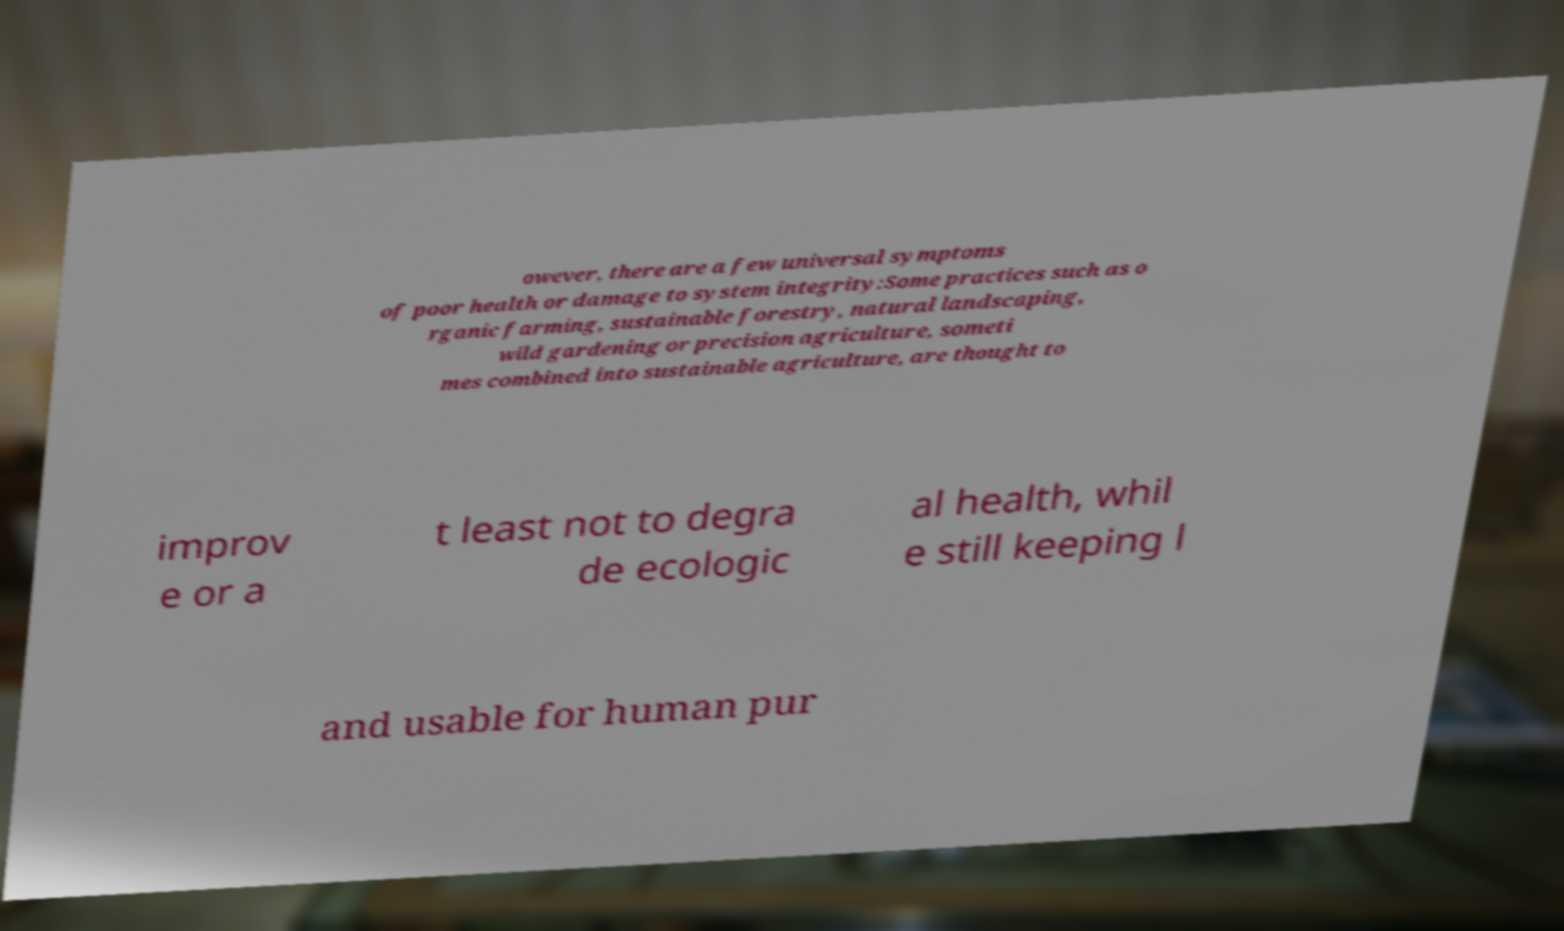Could you assist in decoding the text presented in this image and type it out clearly? owever, there are a few universal symptoms of poor health or damage to system integrity:Some practices such as o rganic farming, sustainable forestry, natural landscaping, wild gardening or precision agriculture, someti mes combined into sustainable agriculture, are thought to improv e or a t least not to degra de ecologic al health, whil e still keeping l and usable for human pur 